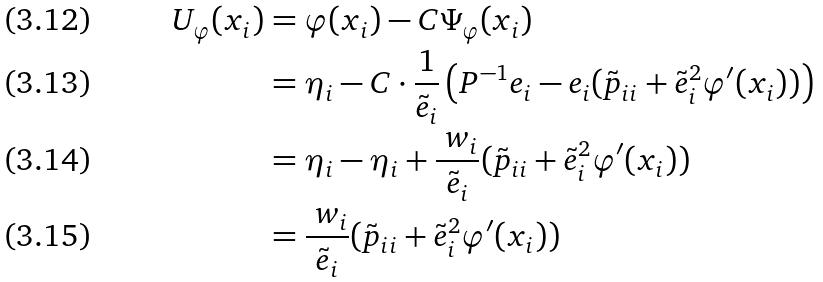<formula> <loc_0><loc_0><loc_500><loc_500>U _ { \varphi } ( x _ { i } ) & = \varphi ( x _ { i } ) - C \Psi _ { \varphi } ( x _ { i } ) \\ & = \eta _ { i } - C \cdot \frac { 1 } { \tilde { e } _ { i } } \left ( P ^ { - 1 } { e } _ { i } - { e } _ { i } ( \tilde { p } _ { i i } + \tilde { e } _ { i } ^ { 2 } \varphi ^ { \prime } ( x _ { i } ) ) \right ) \\ & = \eta _ { i } - \eta _ { i } + \frac { \ w _ { i } } { \tilde { e } _ { i } } ( \tilde { p } _ { i i } + \tilde { e } _ { i } ^ { 2 } \varphi ^ { \prime } ( x _ { i } ) ) \\ & = \frac { \ w _ { i } } { \tilde { e } _ { i } } ( \tilde { p } _ { i i } + \tilde { e } _ { i } ^ { 2 } \varphi ^ { \prime } ( x _ { i } ) )</formula> 